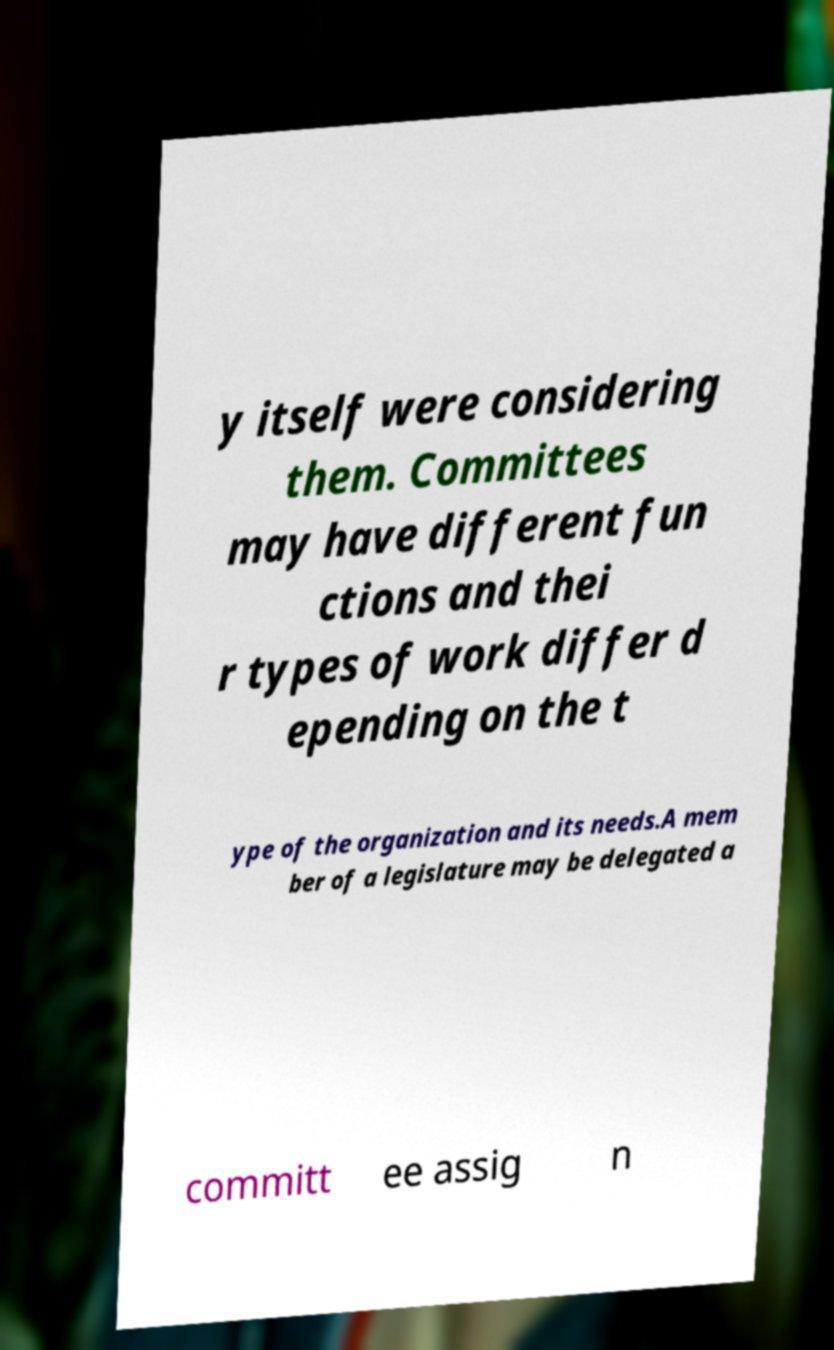Please read and relay the text visible in this image. What does it say? y itself were considering them. Committees may have different fun ctions and thei r types of work differ d epending on the t ype of the organization and its needs.A mem ber of a legislature may be delegated a committ ee assig n 